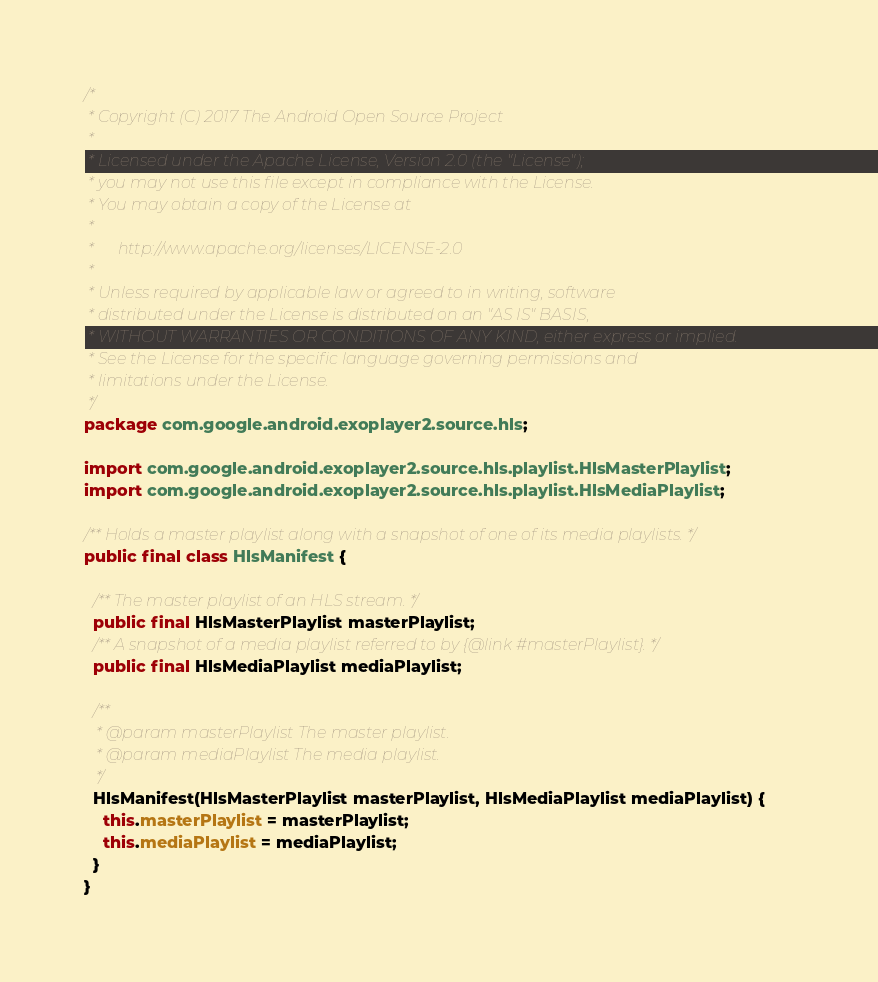Convert code to text. <code><loc_0><loc_0><loc_500><loc_500><_Java_>/*
 * Copyright (C) 2017 The Android Open Source Project
 *
 * Licensed under the Apache License, Version 2.0 (the "License");
 * you may not use this file except in compliance with the License.
 * You may obtain a copy of the License at
 *
 *      http://www.apache.org/licenses/LICENSE-2.0
 *
 * Unless required by applicable law or agreed to in writing, software
 * distributed under the License is distributed on an "AS IS" BASIS,
 * WITHOUT WARRANTIES OR CONDITIONS OF ANY KIND, either express or implied.
 * See the License for the specific language governing permissions and
 * limitations under the License.
 */
package com.google.android.exoplayer2.source.hls;

import com.google.android.exoplayer2.source.hls.playlist.HlsMasterPlaylist;
import com.google.android.exoplayer2.source.hls.playlist.HlsMediaPlaylist;

/** Holds a master playlist along with a snapshot of one of its media playlists. */
public final class HlsManifest {

  /** The master playlist of an HLS stream. */
  public final HlsMasterPlaylist masterPlaylist;
  /** A snapshot of a media playlist referred to by {@link #masterPlaylist}. */
  public final HlsMediaPlaylist mediaPlaylist;

  /**
   * @param masterPlaylist The master playlist.
   * @param mediaPlaylist The media playlist.
   */
  HlsManifest(HlsMasterPlaylist masterPlaylist, HlsMediaPlaylist mediaPlaylist) {
    this.masterPlaylist = masterPlaylist;
    this.mediaPlaylist = mediaPlaylist;
  }
}
</code> 